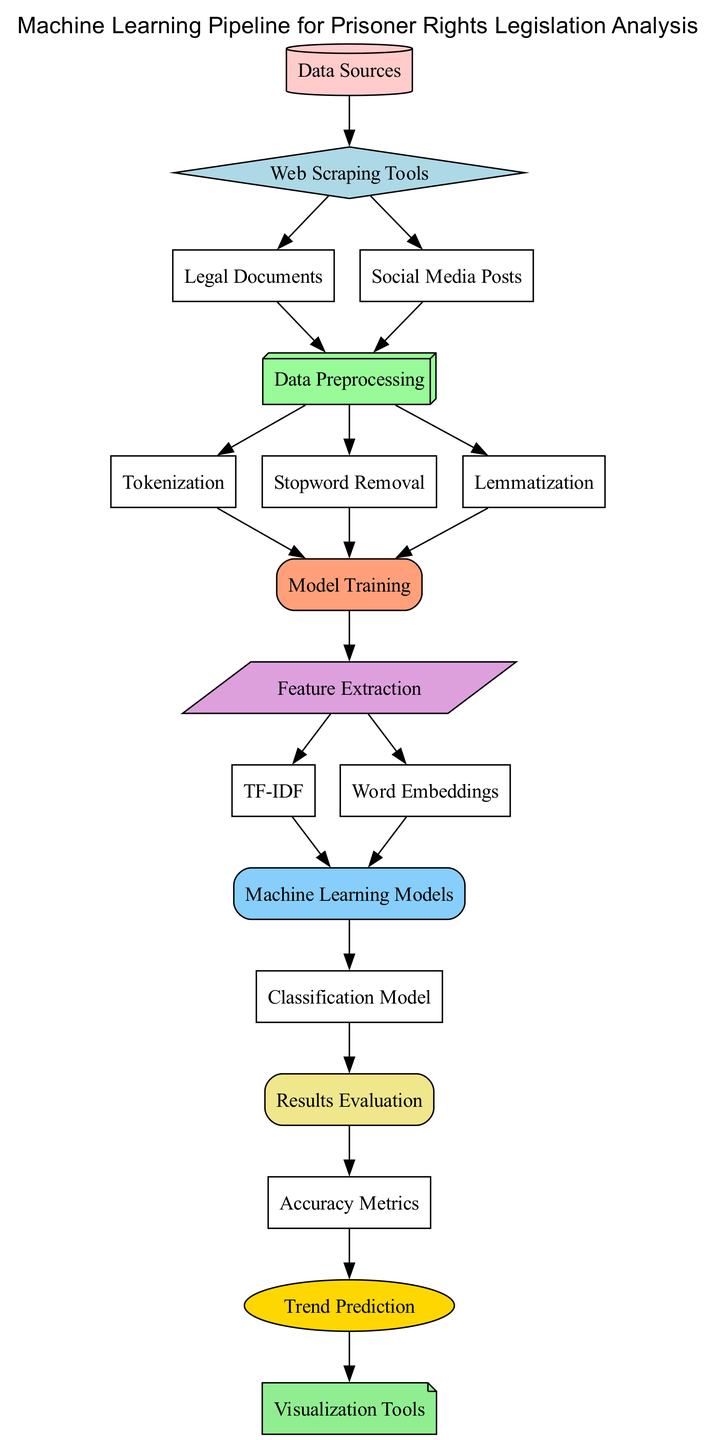What are the starting points of the machine learning process? The starting points in the diagram are represented by the "Data Sources" node, which connects to both "Web Scraping Tools" and "Legal Documents" as well as "Social Media Posts."
Answer: Data Sources How many preprocessing steps are depicted in the diagram? The diagram shows three distinct preprocessing steps: "Tokenization," "Stopword Removal," and "Lemmatization," all stemming from "Data Preprocessing."
Answer: Three Which tools are used for feature extraction? The diagram indicates two specific tools for feature extraction: "TF-IDF" and "Word Embeddings," both leading from the "Feature Extraction" node.
Answer: TF-IDF and Word Embeddings What follows the model training in the process? After "Model Training," the next step is "Feature Extraction," indicating that model training provides input for this feature extraction stage.
Answer: Feature Extraction How is trend prediction evaluated according to the diagram? The diagram shows a connection from "Accuracy Metrics" to "Trend Prediction," indicating that the effectiveness of predictions relies on evaluating accuracy metrics.
Answer: Accuracy Metrics What type of model is used in the machine learning process depicted? The model used is a "Classification Model," as represented in the diagram, which comes after "Machine Learning Models."
Answer: Classification Model Which node represents the final outcome visualization? The final outcome visualization is represented by the "Visualization Tools" node, which is the last step following "Trend Prediction."
Answer: Visualization Tools How many edges are there in total in the diagram? By analyzing the connections depicted in the diagram, there are a total of 21 edges that represent the relationships between the nodes.
Answer: Twenty-one What step comes after data preprocessing in the diagram’s flow? Following "Data Preprocessing," the next step in the flow is "Tokenization," which begins the transformation of raw data into a format suitable for analysis.
Answer: Tokenization 